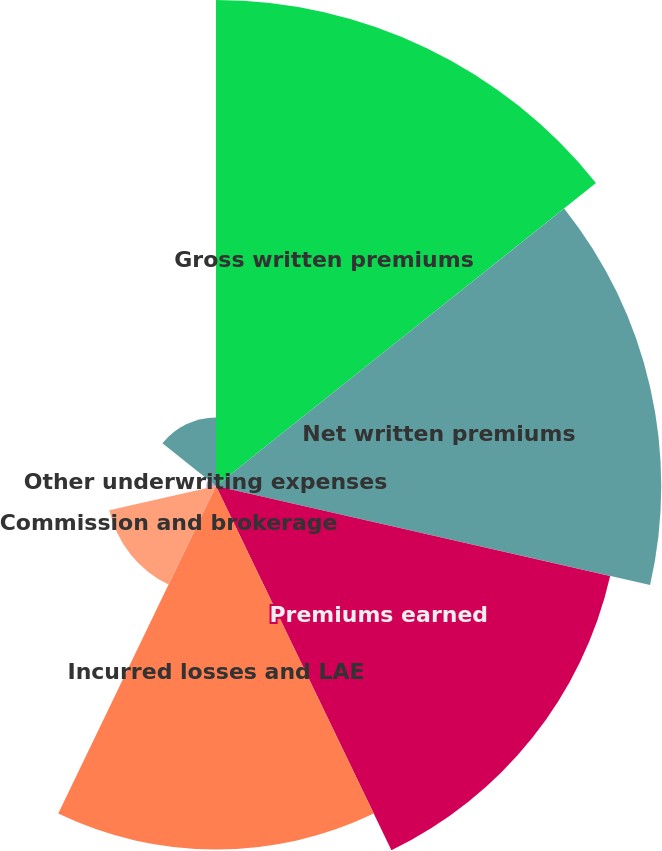Convert chart. <chart><loc_0><loc_0><loc_500><loc_500><pie_chart><fcel>Gross written premiums<fcel>Net written premiums<fcel>Premiums earned<fcel>Incurred losses and LAE<fcel>Commission and brokerage<fcel>Other underwriting expenses<fcel>Underwriting gain (loss)<nl><fcel>25.76%<fcel>23.6%<fcel>21.43%<fcel>19.27%<fcel>5.8%<fcel>0.51%<fcel>3.63%<nl></chart> 